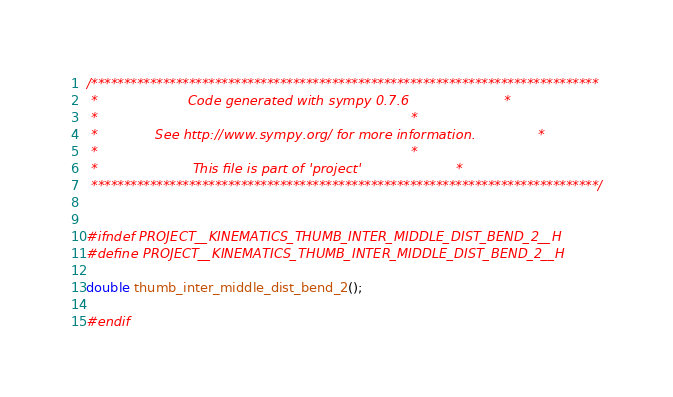<code> <loc_0><loc_0><loc_500><loc_500><_C_>/******************************************************************************
 *                      Code generated with sympy 0.7.6                       *
 *                                                                            *
 *              See http://www.sympy.org/ for more information.               *
 *                                                                            *
 *                       This file is part of 'project'                       *
 ******************************************************************************/


#ifndef PROJECT__KINEMATICS_THUMB_INTER_MIDDLE_DIST_BEND_2__H
#define PROJECT__KINEMATICS_THUMB_INTER_MIDDLE_DIST_BEND_2__H

double thumb_inter_middle_dist_bend_2();

#endif

</code> 